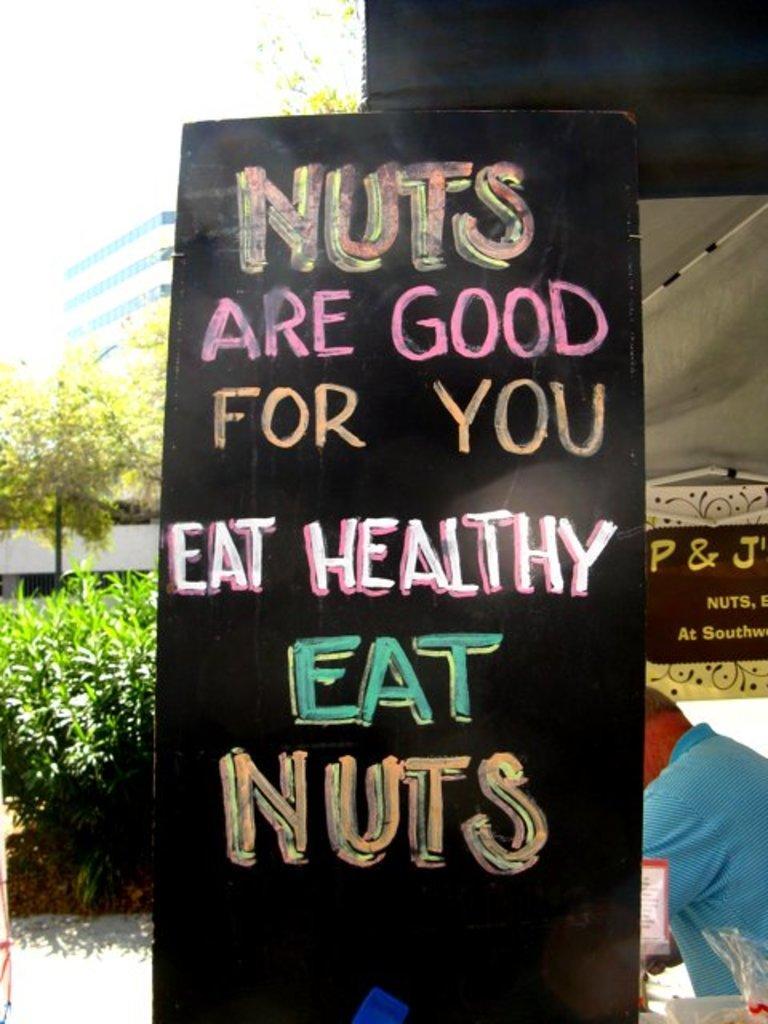Please provide a concise description of this image. In the foreground of this image, there is a black color board and some text on it. On the right, there is a man under the tent. On the left, there is greenery and few buildings. 